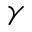<formula> <loc_0><loc_0><loc_500><loc_500>\gamma</formula> 